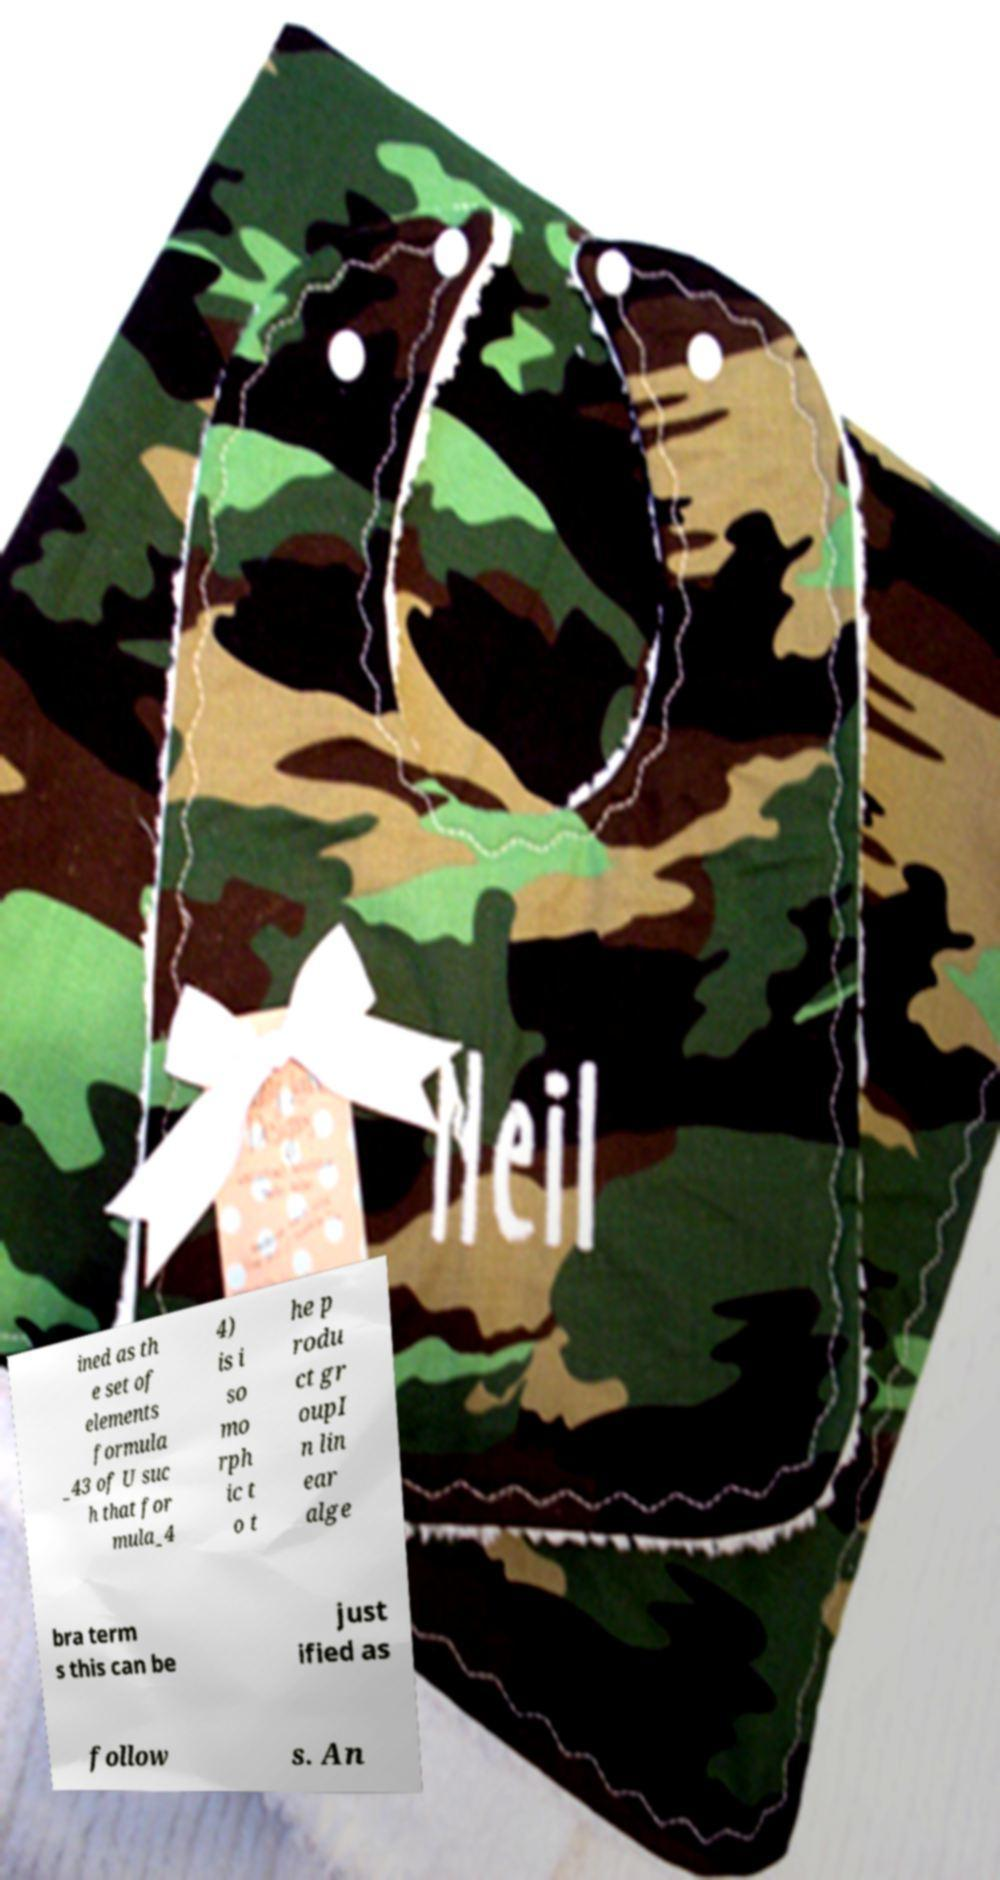Please read and relay the text visible in this image. What does it say? ined as th e set of elements formula _43 of U suc h that for mula_4 4) is i so mo rph ic t o t he p rodu ct gr oupI n lin ear alge bra term s this can be just ified as follow s. An 